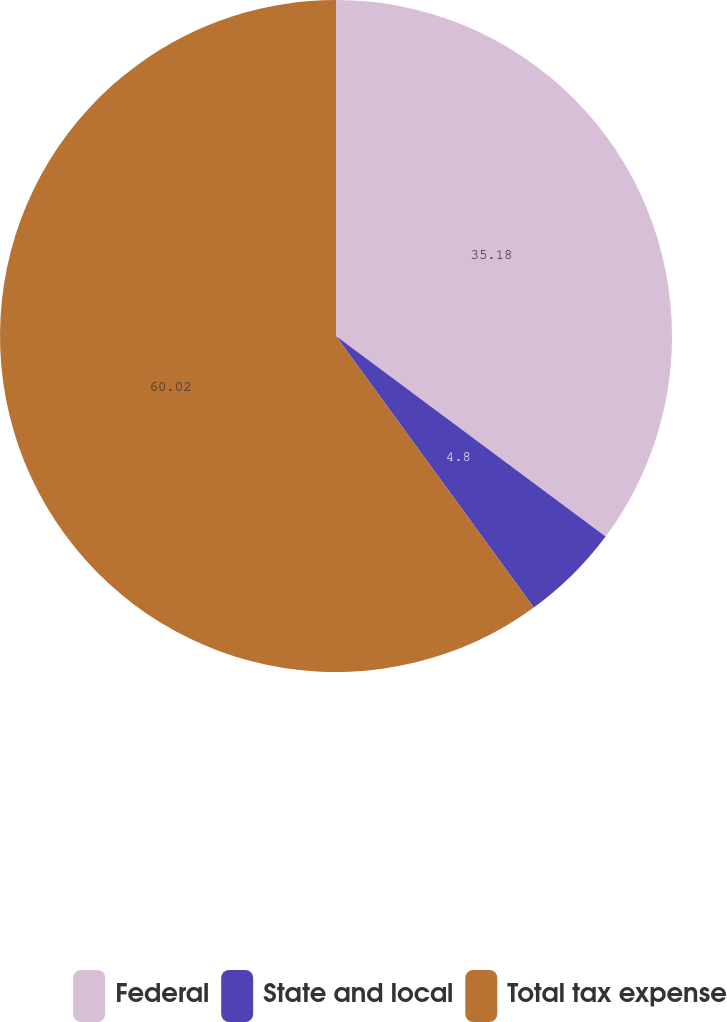<chart> <loc_0><loc_0><loc_500><loc_500><pie_chart><fcel>Federal<fcel>State and local<fcel>Total tax expense<nl><fcel>35.18%<fcel>4.8%<fcel>60.02%<nl></chart> 